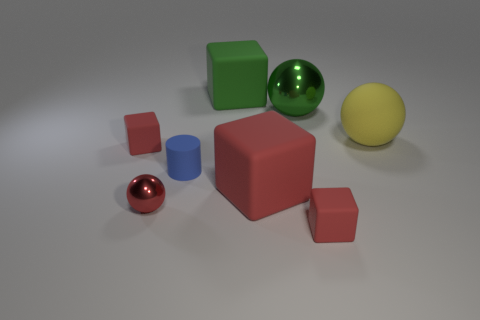What shape is the red metallic thing? The red metallic object in the image is a sphere. It has a reflective surface that captures some of the light and colors of the environment, which accentuates its round, three-dimensional shape. 